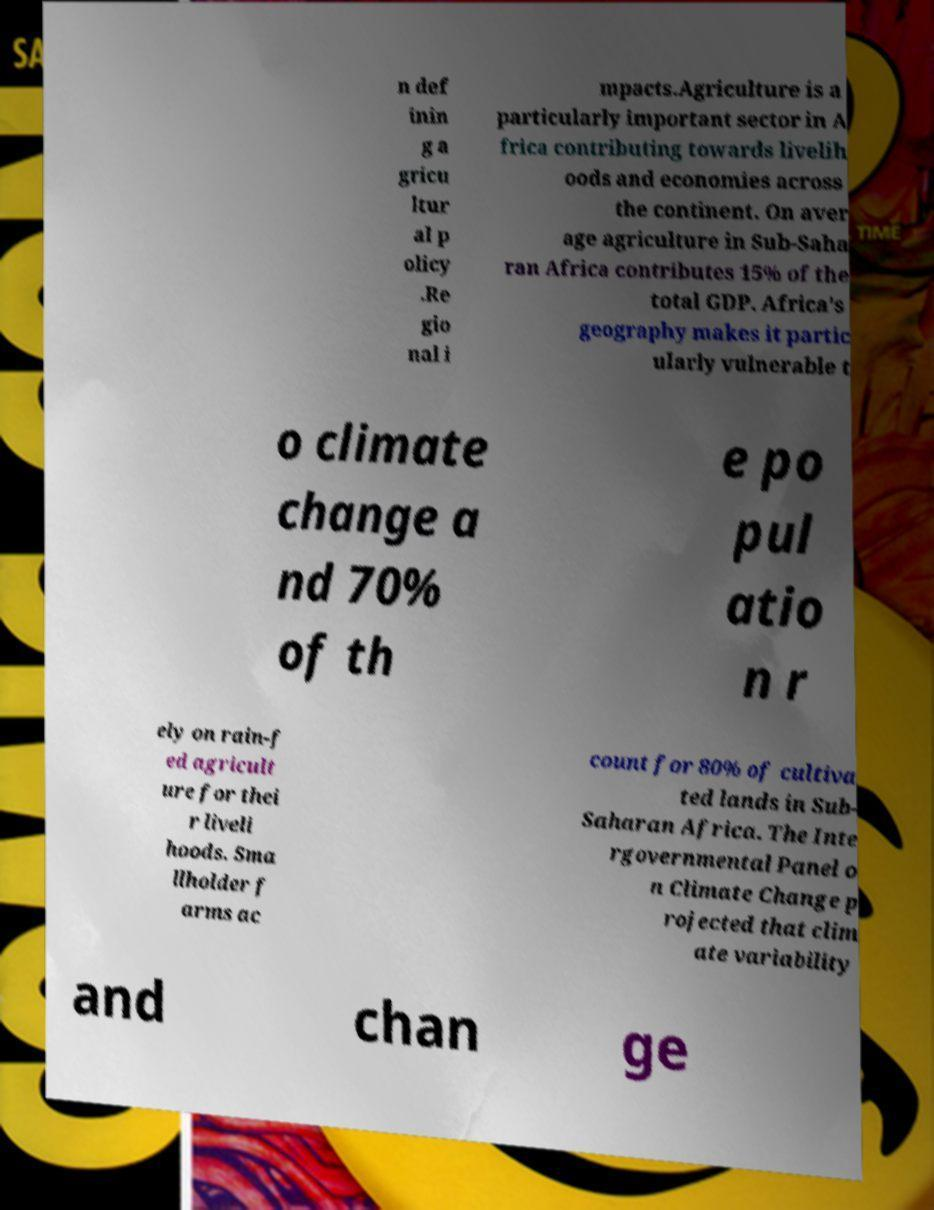I need the written content from this picture converted into text. Can you do that? n def inin g a gricu ltur al p olicy .Re gio nal i mpacts.Agriculture is a particularly important sector in A frica contributing towards livelih oods and economies across the continent. On aver age agriculture in Sub-Saha ran Africa contributes 15% of the total GDP. Africa's geography makes it partic ularly vulnerable t o climate change a nd 70% of th e po pul atio n r ely on rain-f ed agricult ure for thei r liveli hoods. Sma llholder f arms ac count for 80% of cultiva ted lands in Sub- Saharan Africa. The Inte rgovernmental Panel o n Climate Change p rojected that clim ate variability and chan ge 